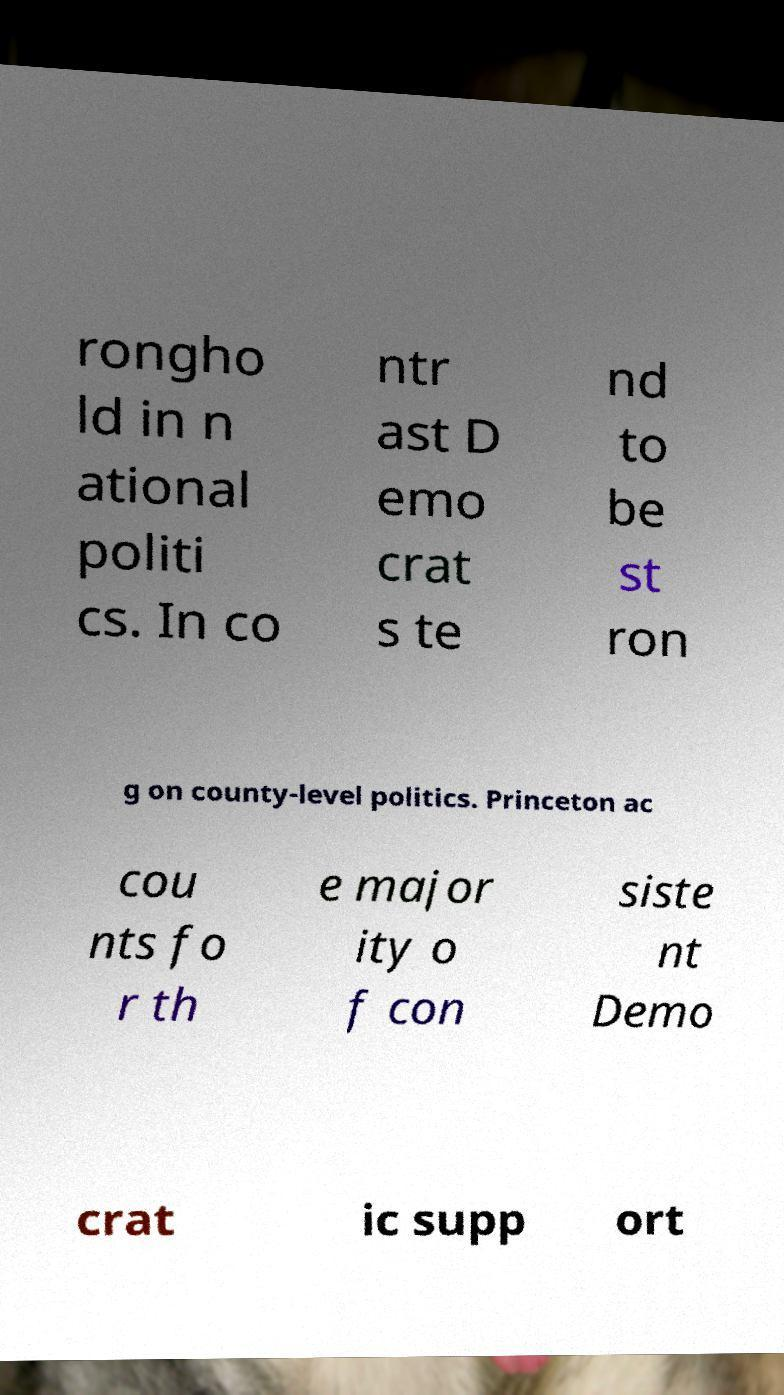Please read and relay the text visible in this image. What does it say? rongho ld in n ational politi cs. In co ntr ast D emo crat s te nd to be st ron g on county-level politics. Princeton ac cou nts fo r th e major ity o f con siste nt Demo crat ic supp ort 